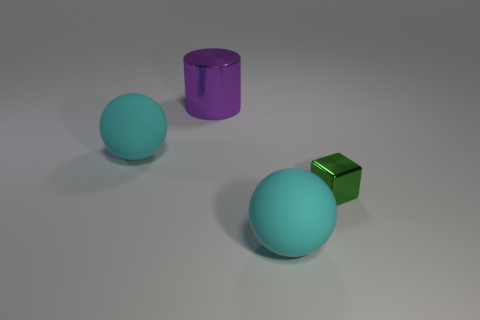Subtract all yellow rubber objects. Subtract all green cubes. How many objects are left? 3 Add 3 tiny blocks. How many tiny blocks are left? 4 Add 1 small green shiny objects. How many small green shiny objects exist? 2 Add 3 purple cylinders. How many objects exist? 7 Subtract 0 gray balls. How many objects are left? 4 Subtract all cubes. How many objects are left? 3 Subtract 1 balls. How many balls are left? 1 Subtract all red cylinders. Subtract all yellow spheres. How many cylinders are left? 1 Subtract all yellow cubes. How many yellow balls are left? 0 